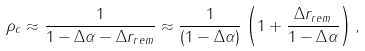<formula> <loc_0><loc_0><loc_500><loc_500>\rho _ { c } \approx \frac { 1 } { 1 - \Delta \alpha - \Delta r _ { r e m } } \approx \frac { 1 } { \left ( 1 - \Delta \alpha \right ) } \left ( 1 + \frac { \Delta r _ { r e m } } { 1 - \Delta \alpha } \right ) ,</formula> 